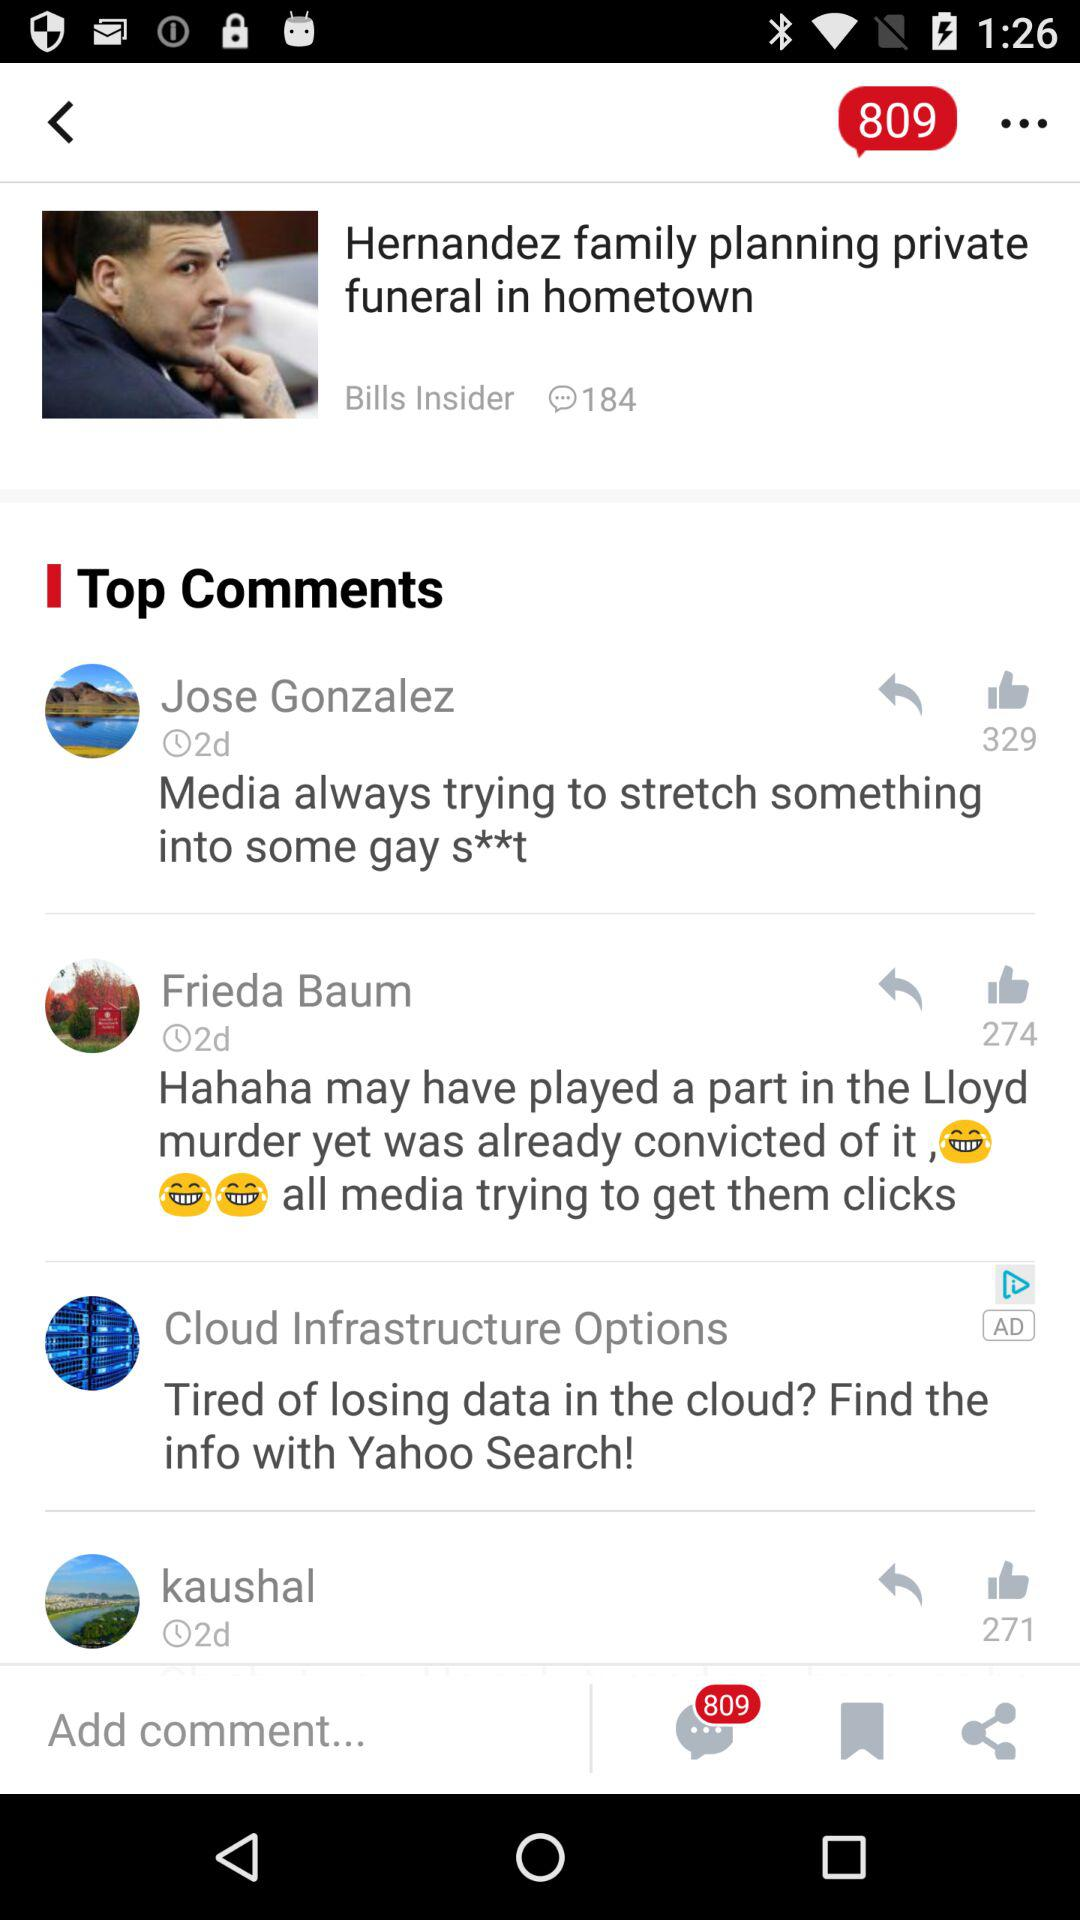How many likes are there of Frieda's comment? There are 274 likes of Frieda's comment. 